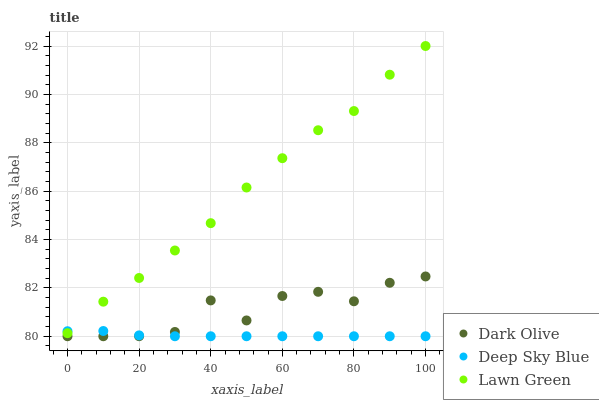Does Deep Sky Blue have the minimum area under the curve?
Answer yes or no. Yes. Does Lawn Green have the maximum area under the curve?
Answer yes or no. Yes. Does Dark Olive have the minimum area under the curve?
Answer yes or no. No. Does Dark Olive have the maximum area under the curve?
Answer yes or no. No. Is Deep Sky Blue the smoothest?
Answer yes or no. Yes. Is Dark Olive the roughest?
Answer yes or no. Yes. Is Dark Olive the smoothest?
Answer yes or no. No. Is Deep Sky Blue the roughest?
Answer yes or no. No. Does Dark Olive have the lowest value?
Answer yes or no. Yes. Does Lawn Green have the highest value?
Answer yes or no. Yes. Does Dark Olive have the highest value?
Answer yes or no. No. Is Dark Olive less than Lawn Green?
Answer yes or no. Yes. Is Lawn Green greater than Dark Olive?
Answer yes or no. Yes. Does Lawn Green intersect Deep Sky Blue?
Answer yes or no. Yes. Is Lawn Green less than Deep Sky Blue?
Answer yes or no. No. Is Lawn Green greater than Deep Sky Blue?
Answer yes or no. No. Does Dark Olive intersect Lawn Green?
Answer yes or no. No. 